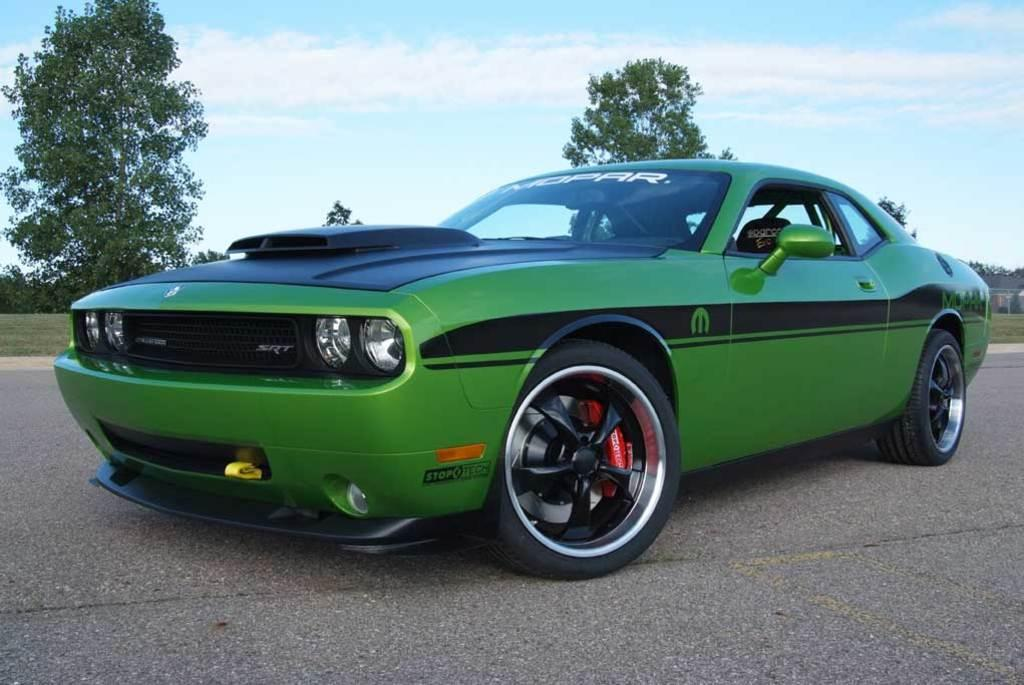What is the main subject of the image? There is a car on the road in the image. What type of environment surrounds the car? There is a grassy land in the image, and there are many trees as well. What can be seen in the sky in the image? There are clouds in the sky in the image. What type of kettle is being used for reading in the image? There is no kettle or reading activity present in the image. 